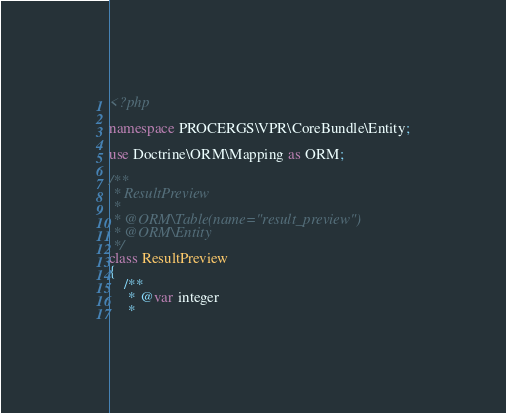<code> <loc_0><loc_0><loc_500><loc_500><_PHP_><?php

namespace PROCERGS\VPR\CoreBundle\Entity;

use Doctrine\ORM\Mapping as ORM;

/**
 * ResultPreview
 *
 * @ORM\Table(name="result_preview")
 * @ORM\Entity
 */
class ResultPreview
{
    /**
     * @var integer
     *</code> 